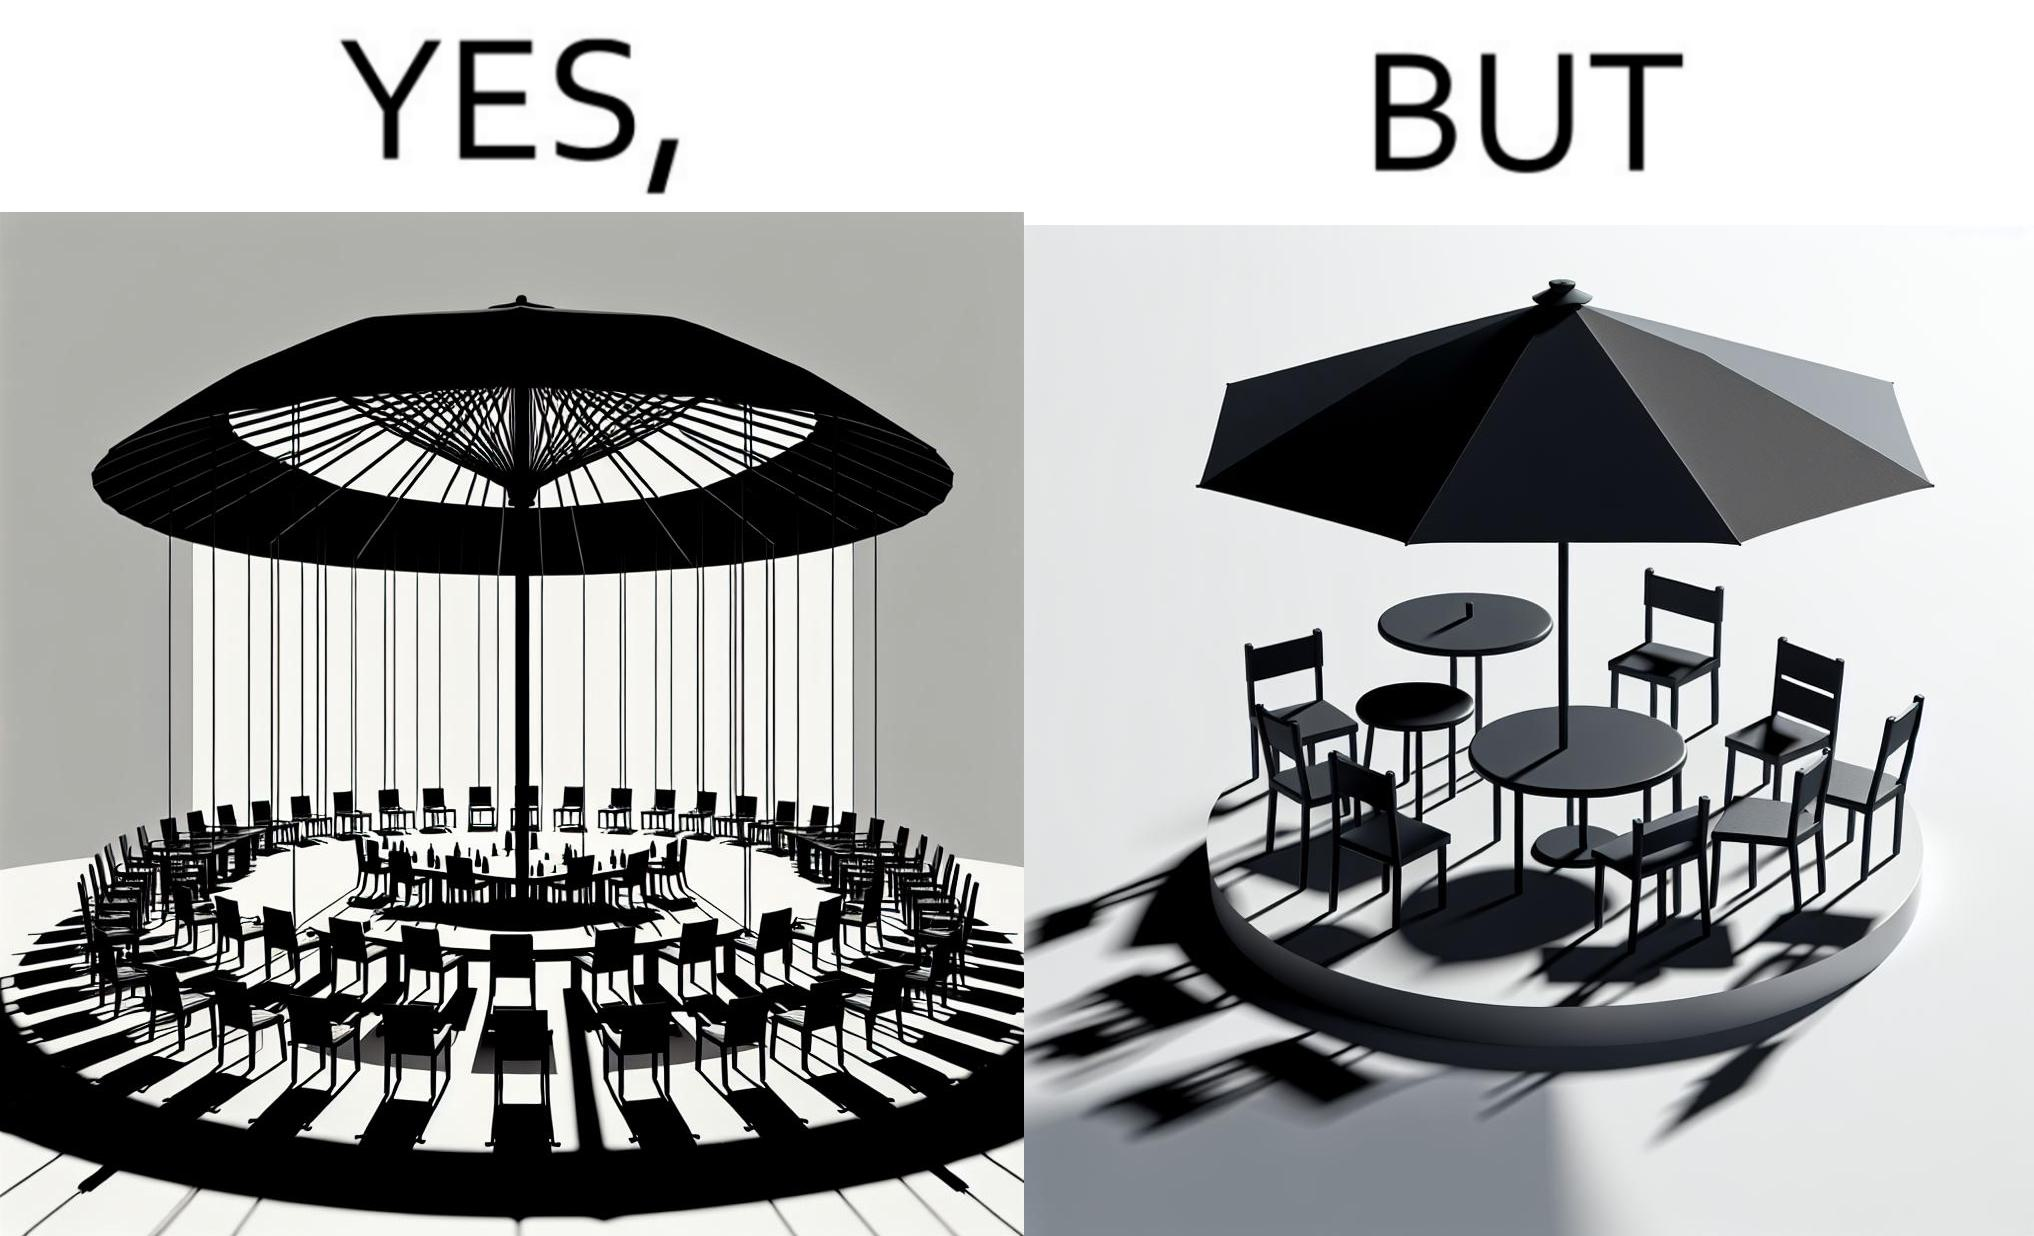Is there satirical content in this image? Yes, this image is satirical. 